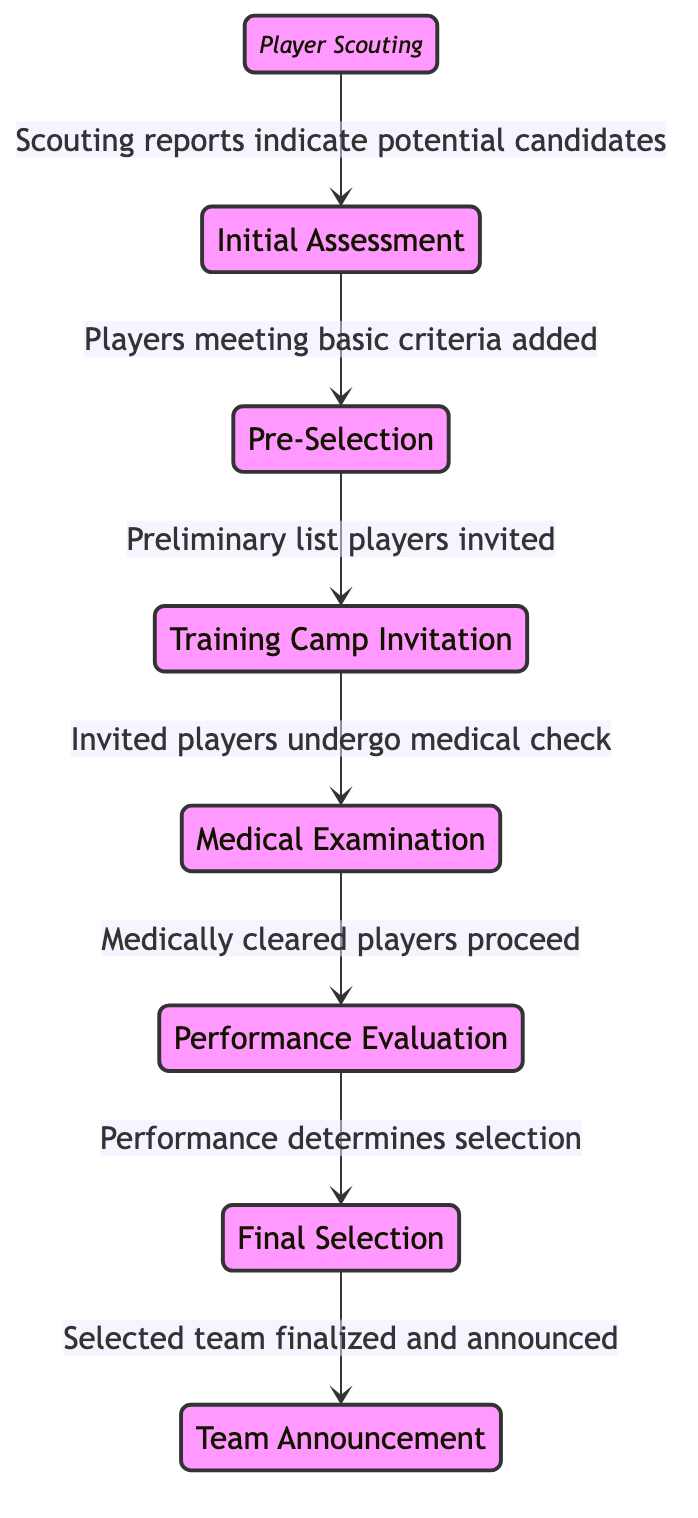What is the first state in the player selection process? The first state listed in the diagram is "PlayerScouting." It is the initial phase for scouted players.
Answer: PlayerScouting How many states are represented in the diagram? The diagram lists a total of eight states: PlayerScouting, InitialAssessment, PreSelection, TrainingCampInvitation, MedicalExamination, PerformanceEvaluation, FinalSelection, and TeamAnnouncement.
Answer: Eight What is the last state in the player selection process? The last state in the diagram is "TeamAnnouncement," which concludes the selection process by announcing the final team.
Answer: TeamAnnouncement Which state follows the "InitialAssessment"? According to the transitions shown in the diagram, "InitialAssessment" transitions to "PreSelection."
Answer: PreSelection What is required for players to proceed from "TrainingCampInvitation" to "MedicalExamination"? Players invited to the training camp must undergo a medical examination, which is indicated as a necessary step.
Answer: Medical examination Which state involves evaluating players through drills and friendly matches? The state where players are evaluated through drills, exercises, and friendly matches is "PerformanceEvaluation."
Answer: PerformanceEvaluation How are players selected for the final team? The state "FinalSelection" indicates that the selection is based on the performance, fitness, and tactical needs assessed during the training camp.
Answer: Performance, fitness, and tactical needs What transition occurs after "PerformanceEvaluation"? Following "PerformanceEvaluation," the transition leads to "FinalSelection," indicating that players' performance during evaluation determines their status.
Answer: FinalSelection What must happen before the "TeamAnnouncement"? Prior to "TeamAnnouncement," the team must go through "FinalSelection," where the selected team is finalized based on evaluations.
Answer: FinalSelection 